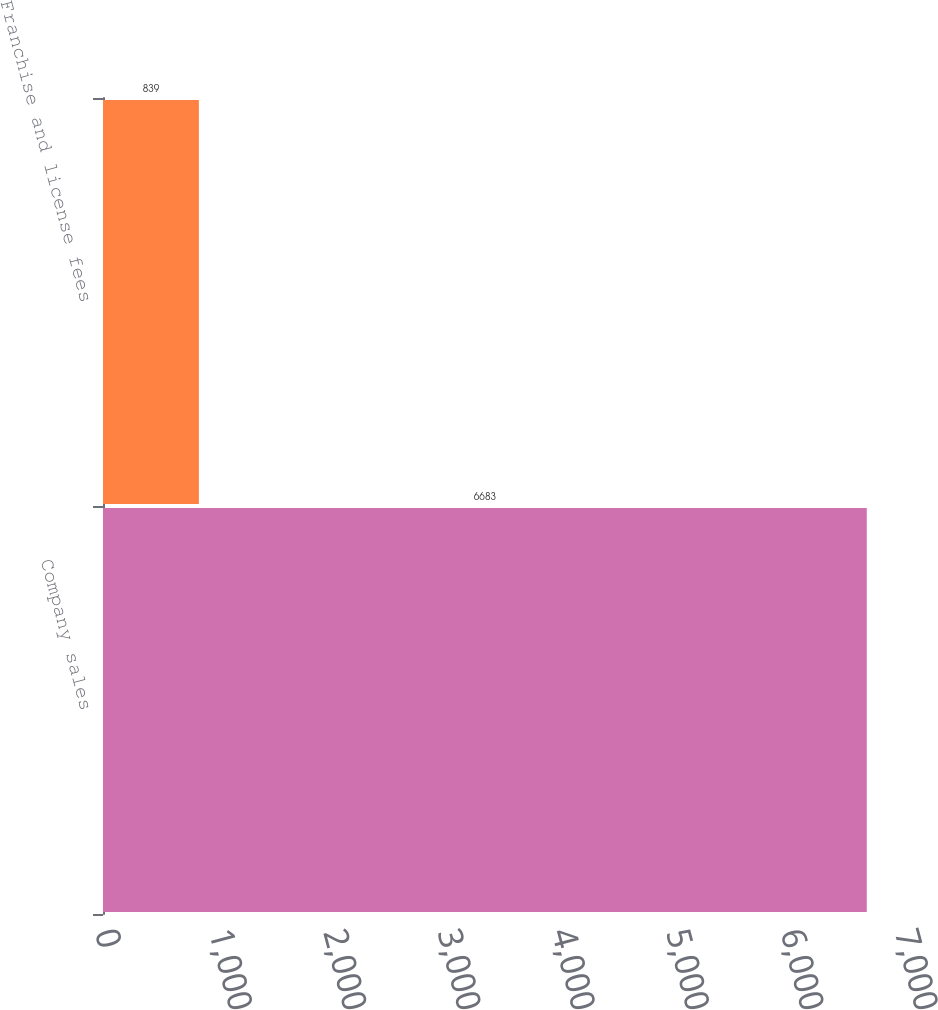<chart> <loc_0><loc_0><loc_500><loc_500><bar_chart><fcel>Company sales<fcel>Franchise and license fees<nl><fcel>6683<fcel>839<nl></chart> 